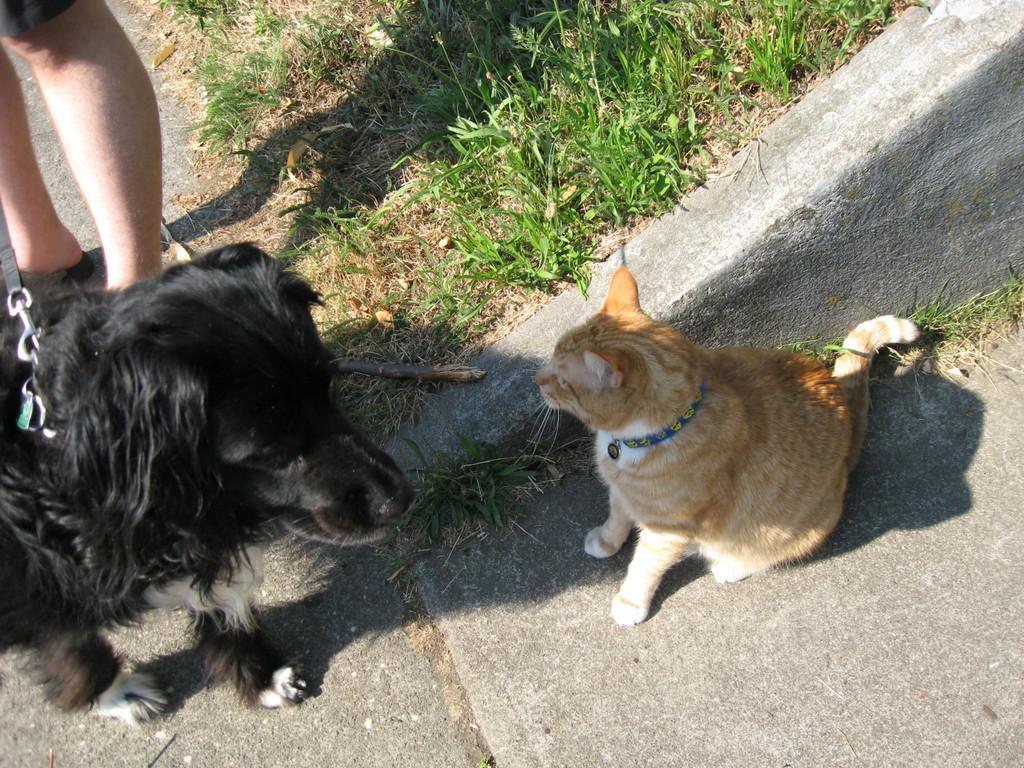How would you summarize this image in a sentence or two? In this image I can see on the left side there is a dog in black color. At the top there are human legs, on the right side there is a cat in brown color, at the top there is the grass. 